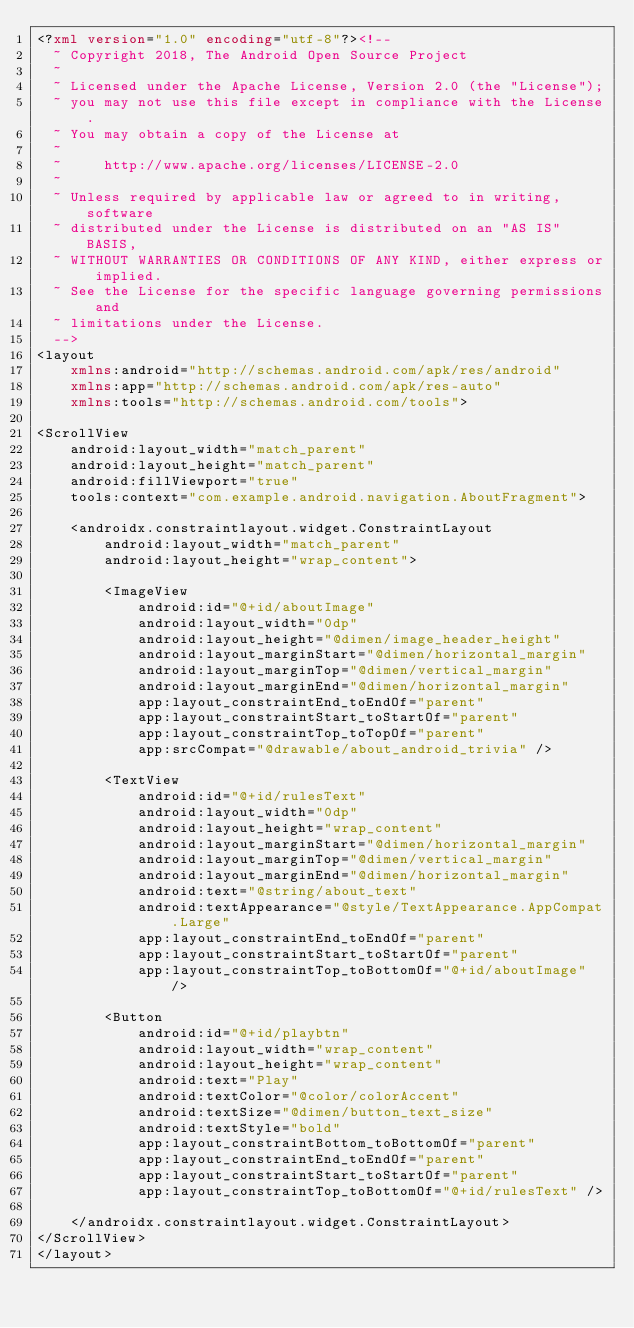Convert code to text. <code><loc_0><loc_0><loc_500><loc_500><_XML_><?xml version="1.0" encoding="utf-8"?><!--
  ~ Copyright 2018, The Android Open Source Project
  ~
  ~ Licensed under the Apache License, Version 2.0 (the "License");
  ~ you may not use this file except in compliance with the License.
  ~ You may obtain a copy of the License at
  ~
  ~     http://www.apache.org/licenses/LICENSE-2.0
  ~
  ~ Unless required by applicable law or agreed to in writing, software
  ~ distributed under the License is distributed on an "AS IS" BASIS,
  ~ WITHOUT WARRANTIES OR CONDITIONS OF ANY KIND, either express or implied.
  ~ See the License for the specific language governing permissions and
  ~ limitations under the License.
  -->
<layout
    xmlns:android="http://schemas.android.com/apk/res/android"
    xmlns:app="http://schemas.android.com/apk/res-auto"
    xmlns:tools="http://schemas.android.com/tools">

<ScrollView 
    android:layout_width="match_parent"
    android:layout_height="match_parent"
    android:fillViewport="true"
    tools:context="com.example.android.navigation.AboutFragment">

    <androidx.constraintlayout.widget.ConstraintLayout
        android:layout_width="match_parent"
        android:layout_height="wrap_content">

        <ImageView
            android:id="@+id/aboutImage"
            android:layout_width="0dp"
            android:layout_height="@dimen/image_header_height"
            android:layout_marginStart="@dimen/horizontal_margin"
            android:layout_marginTop="@dimen/vertical_margin"
            android:layout_marginEnd="@dimen/horizontal_margin"
            app:layout_constraintEnd_toEndOf="parent"
            app:layout_constraintStart_toStartOf="parent"
            app:layout_constraintTop_toTopOf="parent"
            app:srcCompat="@drawable/about_android_trivia" />

        <TextView
            android:id="@+id/rulesText"
            android:layout_width="0dp"
            android:layout_height="wrap_content"
            android:layout_marginStart="@dimen/horizontal_margin"
            android:layout_marginTop="@dimen/vertical_margin"
            android:layout_marginEnd="@dimen/horizontal_margin"
            android:text="@string/about_text"
            android:textAppearance="@style/TextAppearance.AppCompat.Large"
            app:layout_constraintEnd_toEndOf="parent"
            app:layout_constraintStart_toStartOf="parent"
            app:layout_constraintTop_toBottomOf="@+id/aboutImage" />

        <Button
            android:id="@+id/playbtn"
            android:layout_width="wrap_content"
            android:layout_height="wrap_content"
            android:text="Play"
            android:textColor="@color/colorAccent"
            android:textSize="@dimen/button_text_size"
            android:textStyle="bold"
            app:layout_constraintBottom_toBottomOf="parent"
            app:layout_constraintEnd_toEndOf="parent"
            app:layout_constraintStart_toStartOf="parent"
            app:layout_constraintTop_toBottomOf="@+id/rulesText" />

    </androidx.constraintlayout.widget.ConstraintLayout>
</ScrollView>
</layout></code> 